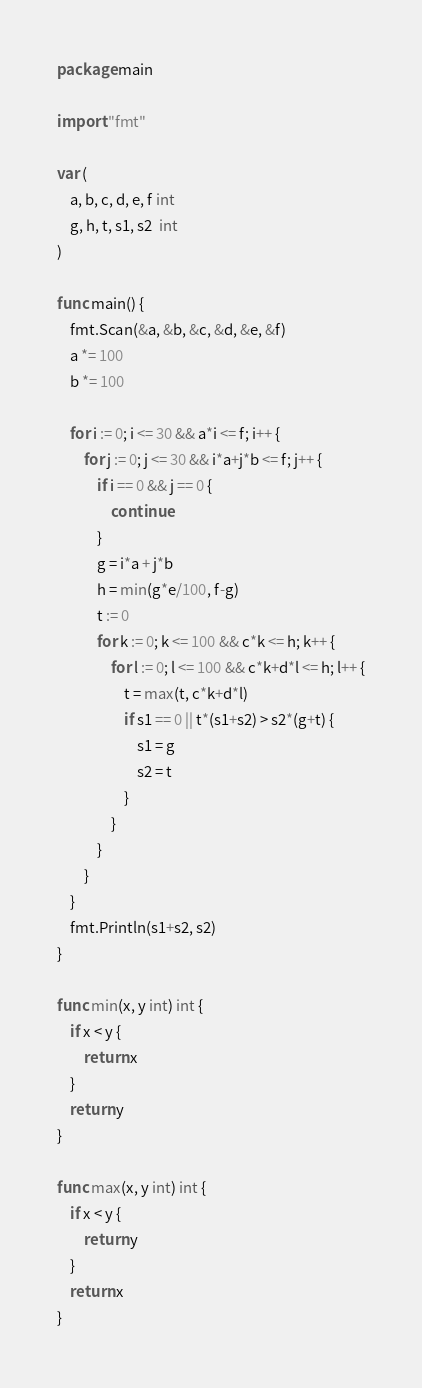Convert code to text. <code><loc_0><loc_0><loc_500><loc_500><_Go_>package main

import "fmt"

var (
	a, b, c, d, e, f int
	g, h, t, s1, s2  int
)

func main() {
	fmt.Scan(&a, &b, &c, &d, &e, &f)
	a *= 100
	b *= 100

	for i := 0; i <= 30 && a*i <= f; i++ {
		for j := 0; j <= 30 && i*a+j*b <= f; j++ {
			if i == 0 && j == 0 {
				continue
			}
			g = i*a + j*b
			h = min(g*e/100, f-g)
			t := 0
			for k := 0; k <= 100 && c*k <= h; k++ {
				for l := 0; l <= 100 && c*k+d*l <= h; l++ {
					t = max(t, c*k+d*l)
					if s1 == 0 || t*(s1+s2) > s2*(g+t) {
						s1 = g
						s2 = t
					}
				}
			}
		}
	}
	fmt.Println(s1+s2, s2)
}

func min(x, y int) int {
	if x < y {
		return x
	}
	return y
}

func max(x, y int) int {
	if x < y {
		return y
	}
	return x
}
</code> 